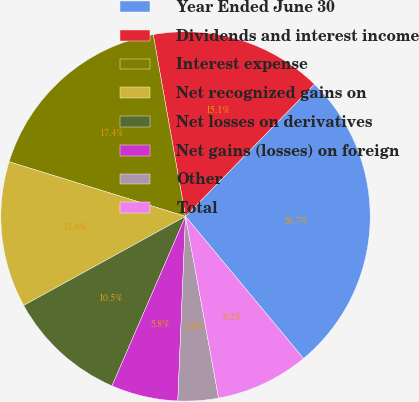<chart> <loc_0><loc_0><loc_500><loc_500><pie_chart><fcel>Year Ended June 30<fcel>Dividends and interest income<fcel>Interest expense<fcel>Net recognized gains on<fcel>Net losses on derivatives<fcel>Net gains (losses) on foreign<fcel>Other<fcel>Total<nl><fcel>26.67%<fcel>15.1%<fcel>17.42%<fcel>12.79%<fcel>10.48%<fcel>5.85%<fcel>3.53%<fcel>8.16%<nl></chart> 